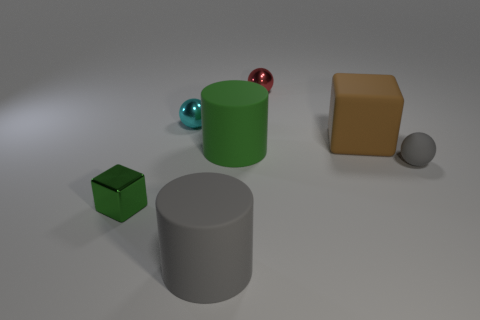What number of gray spheres have the same material as the cyan thing?
Your response must be concise. 0. There is a big object that is the same color as the small shiny block; what shape is it?
Offer a terse response. Cylinder. The thing that is both on the right side of the green metal cube and in front of the gray sphere is made of what material?
Keep it short and to the point. Rubber. What shape is the tiny object in front of the tiny rubber object?
Make the answer very short. Cube. There is a green thing that is right of the gray matte thing in front of the green metal object; what shape is it?
Your answer should be compact. Cylinder. Is there a tiny shiny object of the same shape as the green rubber object?
Provide a short and direct response. No. What is the shape of the green thing that is the same size as the brown matte cube?
Your answer should be compact. Cylinder. Is there a matte object on the right side of the gray rubber thing that is in front of the sphere in front of the big brown block?
Offer a very short reply. Yes. Are there any cylinders of the same size as the brown thing?
Give a very brief answer. Yes. What size is the matte thing in front of the green shiny block?
Provide a short and direct response. Large. 